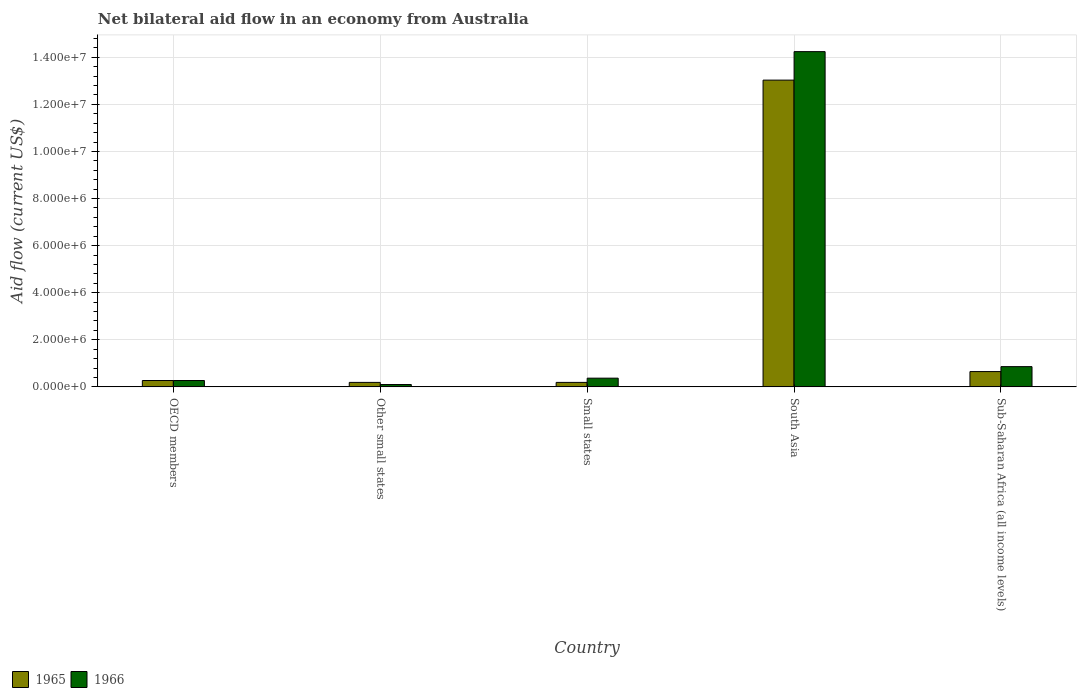How many different coloured bars are there?
Make the answer very short. 2. Are the number of bars on each tick of the X-axis equal?
Offer a very short reply. Yes. How many bars are there on the 4th tick from the left?
Offer a terse response. 2. How many bars are there on the 2nd tick from the right?
Offer a terse response. 2. What is the label of the 3rd group of bars from the left?
Make the answer very short. Small states. What is the net bilateral aid flow in 1966 in South Asia?
Your answer should be compact. 1.42e+07. Across all countries, what is the maximum net bilateral aid flow in 1965?
Offer a terse response. 1.30e+07. In which country was the net bilateral aid flow in 1965 maximum?
Provide a succinct answer. South Asia. In which country was the net bilateral aid flow in 1965 minimum?
Make the answer very short. Other small states. What is the total net bilateral aid flow in 1966 in the graph?
Your response must be concise. 1.58e+07. What is the difference between the net bilateral aid flow in 1966 in OECD members and that in Sub-Saharan Africa (all income levels)?
Provide a short and direct response. -5.90e+05. What is the difference between the net bilateral aid flow in 1966 in Other small states and the net bilateral aid flow in 1965 in Sub-Saharan Africa (all income levels)?
Your answer should be compact. -5.50e+05. What is the average net bilateral aid flow in 1966 per country?
Your answer should be compact. 3.17e+06. What is the ratio of the net bilateral aid flow in 1966 in South Asia to that in Sub-Saharan Africa (all income levels)?
Offer a terse response. 16.56. Is the net bilateral aid flow in 1966 in Small states less than that in Sub-Saharan Africa (all income levels)?
Your answer should be compact. Yes. Is the difference between the net bilateral aid flow in 1966 in South Asia and Sub-Saharan Africa (all income levels) greater than the difference between the net bilateral aid flow in 1965 in South Asia and Sub-Saharan Africa (all income levels)?
Offer a terse response. Yes. What is the difference between the highest and the second highest net bilateral aid flow in 1966?
Provide a succinct answer. 1.39e+07. What is the difference between the highest and the lowest net bilateral aid flow in 1966?
Offer a terse response. 1.41e+07. In how many countries, is the net bilateral aid flow in 1965 greater than the average net bilateral aid flow in 1965 taken over all countries?
Give a very brief answer. 1. What does the 2nd bar from the left in Sub-Saharan Africa (all income levels) represents?
Your answer should be very brief. 1966. What does the 1st bar from the right in Sub-Saharan Africa (all income levels) represents?
Make the answer very short. 1966. How many bars are there?
Offer a terse response. 10. Are all the bars in the graph horizontal?
Provide a short and direct response. No. What is the difference between two consecutive major ticks on the Y-axis?
Provide a short and direct response. 2.00e+06. Are the values on the major ticks of Y-axis written in scientific E-notation?
Your answer should be very brief. Yes. Does the graph contain any zero values?
Ensure brevity in your answer.  No. Does the graph contain grids?
Keep it short and to the point. Yes. What is the title of the graph?
Your answer should be very brief. Net bilateral aid flow in an economy from Australia. Does "1970" appear as one of the legend labels in the graph?
Ensure brevity in your answer.  No. What is the Aid flow (current US$) in 1965 in OECD members?
Offer a terse response. 2.70e+05. What is the Aid flow (current US$) of 1965 in Other small states?
Make the answer very short. 1.90e+05. What is the Aid flow (current US$) in 1966 in Other small states?
Your response must be concise. 1.00e+05. What is the Aid flow (current US$) of 1966 in Small states?
Keep it short and to the point. 3.70e+05. What is the Aid flow (current US$) of 1965 in South Asia?
Keep it short and to the point. 1.30e+07. What is the Aid flow (current US$) in 1966 in South Asia?
Offer a terse response. 1.42e+07. What is the Aid flow (current US$) of 1965 in Sub-Saharan Africa (all income levels)?
Offer a terse response. 6.50e+05. What is the Aid flow (current US$) of 1966 in Sub-Saharan Africa (all income levels)?
Your answer should be compact. 8.60e+05. Across all countries, what is the maximum Aid flow (current US$) in 1965?
Give a very brief answer. 1.30e+07. Across all countries, what is the maximum Aid flow (current US$) in 1966?
Offer a very short reply. 1.42e+07. Across all countries, what is the minimum Aid flow (current US$) in 1966?
Offer a very short reply. 1.00e+05. What is the total Aid flow (current US$) of 1965 in the graph?
Keep it short and to the point. 1.43e+07. What is the total Aid flow (current US$) of 1966 in the graph?
Offer a very short reply. 1.58e+07. What is the difference between the Aid flow (current US$) in 1966 in OECD members and that in Other small states?
Provide a succinct answer. 1.70e+05. What is the difference between the Aid flow (current US$) of 1965 in OECD members and that in South Asia?
Provide a short and direct response. -1.28e+07. What is the difference between the Aid flow (current US$) of 1966 in OECD members and that in South Asia?
Your response must be concise. -1.40e+07. What is the difference between the Aid flow (current US$) in 1965 in OECD members and that in Sub-Saharan Africa (all income levels)?
Keep it short and to the point. -3.80e+05. What is the difference between the Aid flow (current US$) in 1966 in OECD members and that in Sub-Saharan Africa (all income levels)?
Give a very brief answer. -5.90e+05. What is the difference between the Aid flow (current US$) in 1966 in Other small states and that in Small states?
Make the answer very short. -2.70e+05. What is the difference between the Aid flow (current US$) of 1965 in Other small states and that in South Asia?
Give a very brief answer. -1.28e+07. What is the difference between the Aid flow (current US$) in 1966 in Other small states and that in South Asia?
Give a very brief answer. -1.41e+07. What is the difference between the Aid flow (current US$) of 1965 in Other small states and that in Sub-Saharan Africa (all income levels)?
Make the answer very short. -4.60e+05. What is the difference between the Aid flow (current US$) of 1966 in Other small states and that in Sub-Saharan Africa (all income levels)?
Offer a terse response. -7.60e+05. What is the difference between the Aid flow (current US$) of 1965 in Small states and that in South Asia?
Provide a short and direct response. -1.28e+07. What is the difference between the Aid flow (current US$) in 1966 in Small states and that in South Asia?
Provide a succinct answer. -1.39e+07. What is the difference between the Aid flow (current US$) in 1965 in Small states and that in Sub-Saharan Africa (all income levels)?
Ensure brevity in your answer.  -4.60e+05. What is the difference between the Aid flow (current US$) of 1966 in Small states and that in Sub-Saharan Africa (all income levels)?
Provide a short and direct response. -4.90e+05. What is the difference between the Aid flow (current US$) in 1965 in South Asia and that in Sub-Saharan Africa (all income levels)?
Give a very brief answer. 1.24e+07. What is the difference between the Aid flow (current US$) in 1966 in South Asia and that in Sub-Saharan Africa (all income levels)?
Keep it short and to the point. 1.34e+07. What is the difference between the Aid flow (current US$) of 1965 in OECD members and the Aid flow (current US$) of 1966 in South Asia?
Keep it short and to the point. -1.40e+07. What is the difference between the Aid flow (current US$) of 1965 in OECD members and the Aid flow (current US$) of 1966 in Sub-Saharan Africa (all income levels)?
Give a very brief answer. -5.90e+05. What is the difference between the Aid flow (current US$) of 1965 in Other small states and the Aid flow (current US$) of 1966 in South Asia?
Keep it short and to the point. -1.40e+07. What is the difference between the Aid flow (current US$) in 1965 in Other small states and the Aid flow (current US$) in 1966 in Sub-Saharan Africa (all income levels)?
Provide a short and direct response. -6.70e+05. What is the difference between the Aid flow (current US$) in 1965 in Small states and the Aid flow (current US$) in 1966 in South Asia?
Ensure brevity in your answer.  -1.40e+07. What is the difference between the Aid flow (current US$) of 1965 in Small states and the Aid flow (current US$) of 1966 in Sub-Saharan Africa (all income levels)?
Provide a succinct answer. -6.70e+05. What is the difference between the Aid flow (current US$) in 1965 in South Asia and the Aid flow (current US$) in 1966 in Sub-Saharan Africa (all income levels)?
Offer a terse response. 1.22e+07. What is the average Aid flow (current US$) of 1965 per country?
Ensure brevity in your answer.  2.87e+06. What is the average Aid flow (current US$) in 1966 per country?
Provide a succinct answer. 3.17e+06. What is the difference between the Aid flow (current US$) of 1965 and Aid flow (current US$) of 1966 in OECD members?
Your answer should be compact. 0. What is the difference between the Aid flow (current US$) in 1965 and Aid flow (current US$) in 1966 in Other small states?
Your answer should be very brief. 9.00e+04. What is the difference between the Aid flow (current US$) in 1965 and Aid flow (current US$) in 1966 in Small states?
Your response must be concise. -1.80e+05. What is the difference between the Aid flow (current US$) of 1965 and Aid flow (current US$) of 1966 in South Asia?
Give a very brief answer. -1.21e+06. What is the difference between the Aid flow (current US$) in 1965 and Aid flow (current US$) in 1966 in Sub-Saharan Africa (all income levels)?
Your answer should be very brief. -2.10e+05. What is the ratio of the Aid flow (current US$) of 1965 in OECD members to that in Other small states?
Provide a succinct answer. 1.42. What is the ratio of the Aid flow (current US$) of 1966 in OECD members to that in Other small states?
Keep it short and to the point. 2.7. What is the ratio of the Aid flow (current US$) of 1965 in OECD members to that in Small states?
Provide a short and direct response. 1.42. What is the ratio of the Aid flow (current US$) in 1966 in OECD members to that in Small states?
Give a very brief answer. 0.73. What is the ratio of the Aid flow (current US$) in 1965 in OECD members to that in South Asia?
Provide a succinct answer. 0.02. What is the ratio of the Aid flow (current US$) of 1966 in OECD members to that in South Asia?
Keep it short and to the point. 0.02. What is the ratio of the Aid flow (current US$) in 1965 in OECD members to that in Sub-Saharan Africa (all income levels)?
Your answer should be compact. 0.42. What is the ratio of the Aid flow (current US$) of 1966 in OECD members to that in Sub-Saharan Africa (all income levels)?
Keep it short and to the point. 0.31. What is the ratio of the Aid flow (current US$) of 1965 in Other small states to that in Small states?
Your response must be concise. 1. What is the ratio of the Aid flow (current US$) in 1966 in Other small states to that in Small states?
Provide a short and direct response. 0.27. What is the ratio of the Aid flow (current US$) of 1965 in Other small states to that in South Asia?
Provide a succinct answer. 0.01. What is the ratio of the Aid flow (current US$) of 1966 in Other small states to that in South Asia?
Give a very brief answer. 0.01. What is the ratio of the Aid flow (current US$) of 1965 in Other small states to that in Sub-Saharan Africa (all income levels)?
Give a very brief answer. 0.29. What is the ratio of the Aid flow (current US$) in 1966 in Other small states to that in Sub-Saharan Africa (all income levels)?
Your response must be concise. 0.12. What is the ratio of the Aid flow (current US$) in 1965 in Small states to that in South Asia?
Keep it short and to the point. 0.01. What is the ratio of the Aid flow (current US$) of 1966 in Small states to that in South Asia?
Your answer should be compact. 0.03. What is the ratio of the Aid flow (current US$) of 1965 in Small states to that in Sub-Saharan Africa (all income levels)?
Ensure brevity in your answer.  0.29. What is the ratio of the Aid flow (current US$) in 1966 in Small states to that in Sub-Saharan Africa (all income levels)?
Offer a terse response. 0.43. What is the ratio of the Aid flow (current US$) in 1965 in South Asia to that in Sub-Saharan Africa (all income levels)?
Ensure brevity in your answer.  20.05. What is the ratio of the Aid flow (current US$) in 1966 in South Asia to that in Sub-Saharan Africa (all income levels)?
Your answer should be very brief. 16.56. What is the difference between the highest and the second highest Aid flow (current US$) of 1965?
Make the answer very short. 1.24e+07. What is the difference between the highest and the second highest Aid flow (current US$) in 1966?
Offer a terse response. 1.34e+07. What is the difference between the highest and the lowest Aid flow (current US$) of 1965?
Ensure brevity in your answer.  1.28e+07. What is the difference between the highest and the lowest Aid flow (current US$) in 1966?
Give a very brief answer. 1.41e+07. 